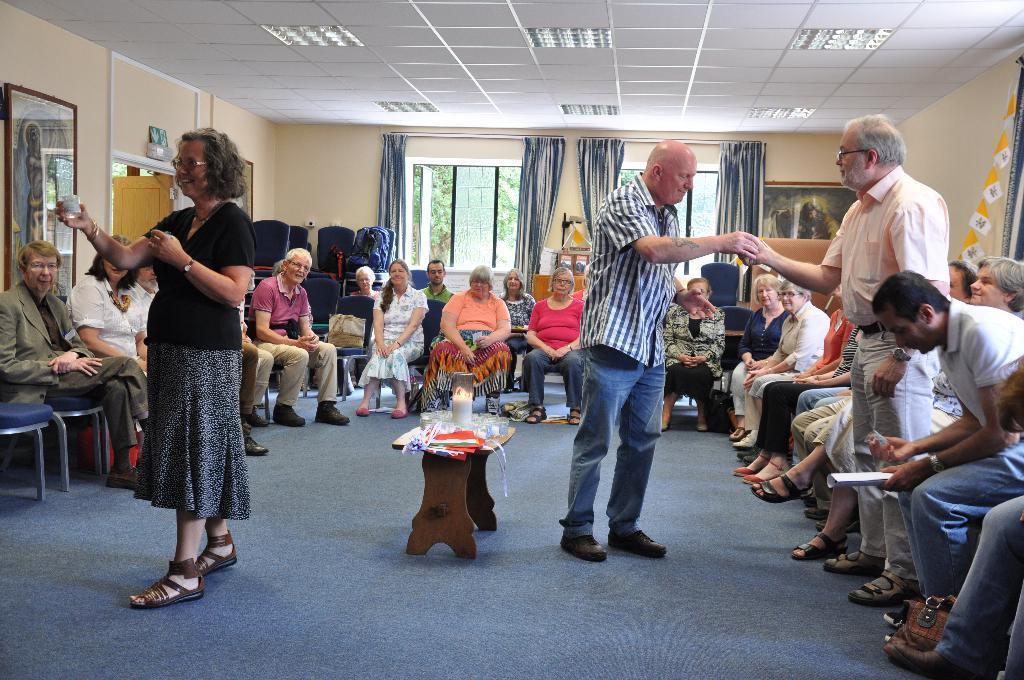Please provide a concise description of this image. In this image I can see a woman standing wearing a black shirt and black skirt. She is holding some object in her hand. I can see two men standing and holding their hands. I can see a group of people sitting on the chairs. I can see a bag placed on the chair. This is a tea point where some objects and a candle is placed on the table. I can see a small bag which is kept on the floor. This man is sitting and holding a paper on his hand. I can see a photo frame which is attached to the wall. At background I can see a window which is opened and a curtain which is hanged to the hanger. The rooftop is having the ceiling light. I can see the trees from the window which is not clear enough. There are chairs arranged in an order. 